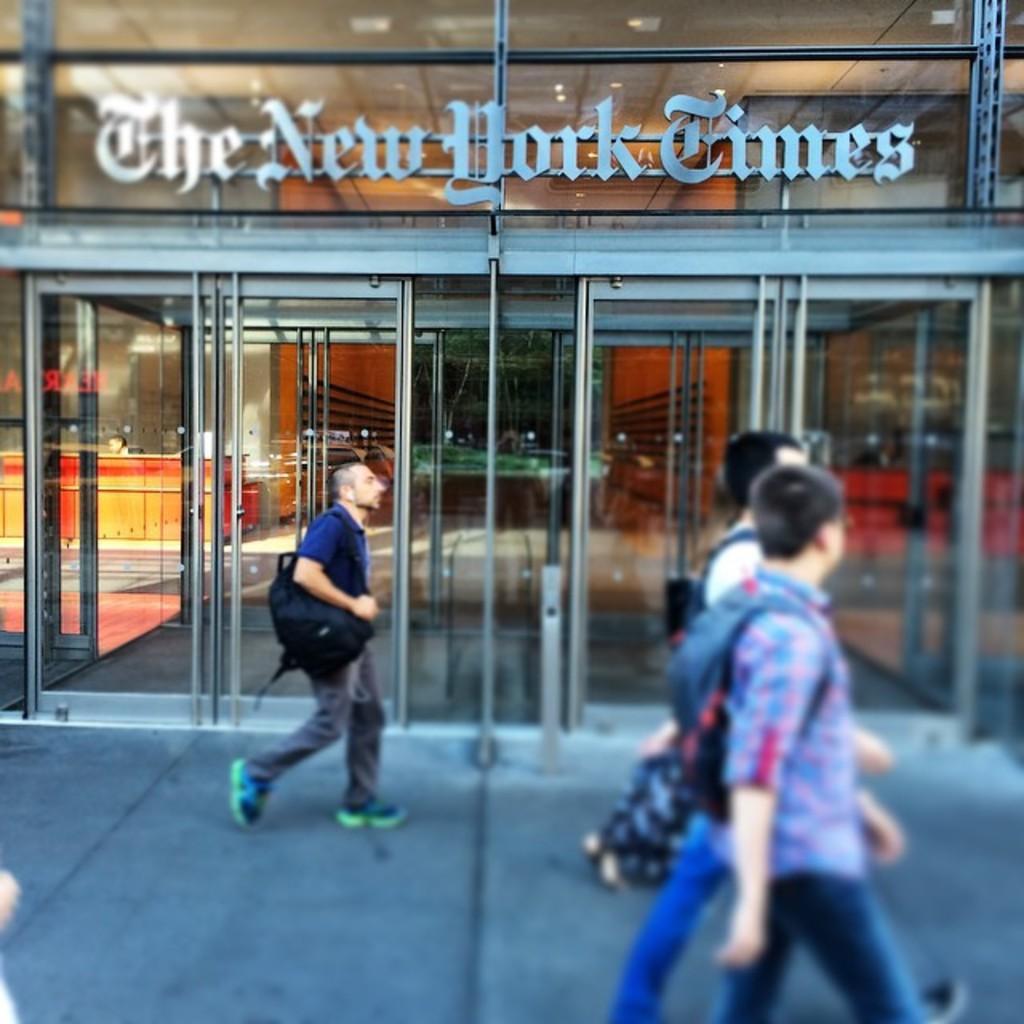In one or two sentences, can you explain what this image depicts? In the picture we can see some people are walking in front of the shop, it is with glass doors and the name of the shop is The New York Times. 